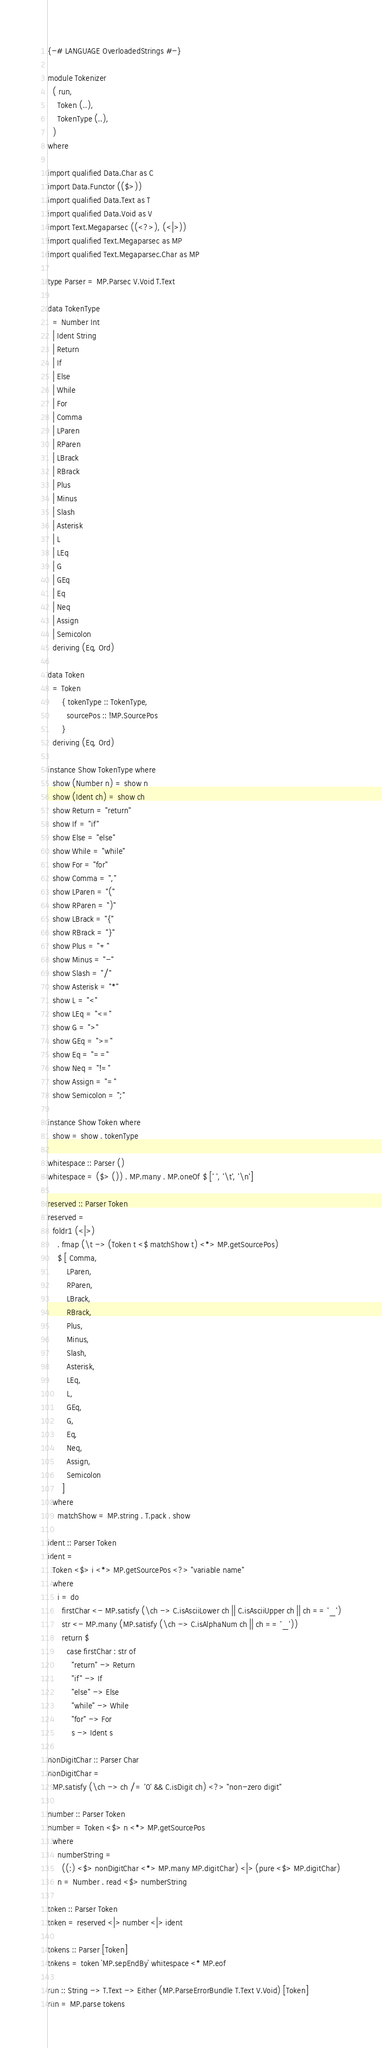<code> <loc_0><loc_0><loc_500><loc_500><_Haskell_>{-# LANGUAGE OverloadedStrings #-}

module Tokenizer
  ( run,
    Token (..),
    TokenType (..),
  )
where

import qualified Data.Char as C
import Data.Functor (($>))
import qualified Data.Text as T
import qualified Data.Void as V
import Text.Megaparsec ((<?>), (<|>))
import qualified Text.Megaparsec as MP
import qualified Text.Megaparsec.Char as MP

type Parser = MP.Parsec V.Void T.Text

data TokenType
  = Number Int
  | Ident String
  | Return
  | If
  | Else
  | While
  | For
  | Comma
  | LParen
  | RParen
  | LBrack
  | RBrack
  | Plus
  | Minus
  | Slash
  | Asterisk
  | L
  | LEq
  | G
  | GEq
  | Eq
  | Neq
  | Assign
  | Semicolon
  deriving (Eq, Ord)

data Token
  = Token
      { tokenType :: TokenType,
        sourcePos :: !MP.SourcePos
      }
  deriving (Eq, Ord)

instance Show TokenType where
  show (Number n) = show n
  show (Ident ch) = show ch
  show Return = "return"
  show If = "if"
  show Else = "else"
  show While = "while"
  show For = "for"
  show Comma = ","
  show LParen = "("
  show RParen = ")"
  show LBrack = "{"
  show RBrack = "}"
  show Plus = "+"
  show Minus = "-"
  show Slash = "/"
  show Asterisk = "*"
  show L = "<"
  show LEq = "<="
  show G = ">"
  show GEq = ">="
  show Eq = "=="
  show Neq = "!="
  show Assign = "="
  show Semicolon = ";"

instance Show Token where
  show = show . tokenType

whitespace :: Parser ()
whitespace = ($> ()) . MP.many . MP.oneOf $ [' ', '\t', '\n']

reserved :: Parser Token
reserved =
  foldr1 (<|>)
    . fmap (\t -> (Token t <$ matchShow t) <*> MP.getSourcePos)
    $ [ Comma,
        LParen,
        RParen,
        LBrack,
        RBrack,
        Plus,
        Minus,
        Slash,
        Asterisk,
        LEq,
        L,
        GEq,
        G,
        Eq,
        Neq,
        Assign,
        Semicolon
      ]
  where
    matchShow = MP.string . T.pack . show

ident :: Parser Token
ident =
  Token <$> i <*> MP.getSourcePos <?> "variable name"
  where
    i = do
      firstChar <- MP.satisfy (\ch -> C.isAsciiLower ch || C.isAsciiUpper ch || ch == '_')
      str <- MP.many (MP.satisfy (\ch -> C.isAlphaNum ch || ch == '_'))
      return $
        case firstChar : str of
          "return" -> Return
          "if" -> If
          "else" -> Else
          "while" -> While
          "for" -> For
          s -> Ident s

nonDigitChar :: Parser Char
nonDigitChar =
  MP.satisfy (\ch -> ch /= '0' && C.isDigit ch) <?> "non-zero digit"

number :: Parser Token
number = Token <$> n <*> MP.getSourcePos
  where
    numberString =
      ((:) <$> nonDigitChar <*> MP.many MP.digitChar) <|> (pure <$> MP.digitChar)
    n = Number . read <$> numberString

token :: Parser Token
token = reserved <|> number <|> ident

tokens :: Parser [Token]
tokens = token `MP.sepEndBy` whitespace <* MP.eof

run :: String -> T.Text -> Either (MP.ParseErrorBundle T.Text V.Void) [Token]
run = MP.parse tokens
</code> 